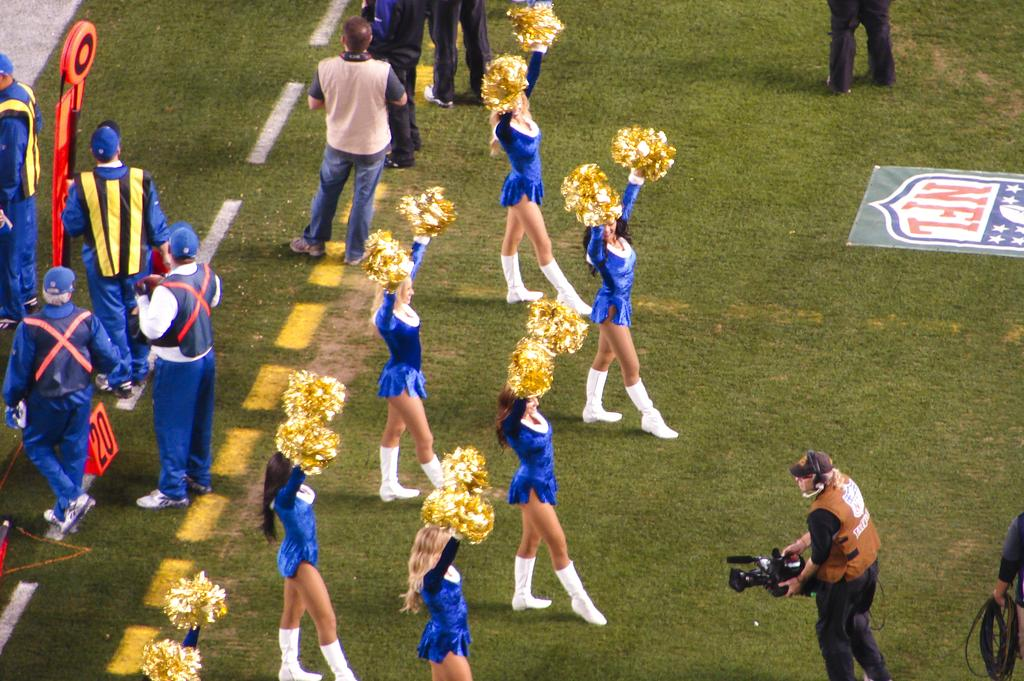<image>
Offer a succinct explanation of the picture presented. Several cheerleaders, staff, and camera men stand on a field for NFL. 